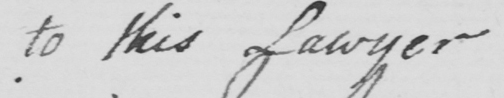What is written in this line of handwriting? to this Lawyer 